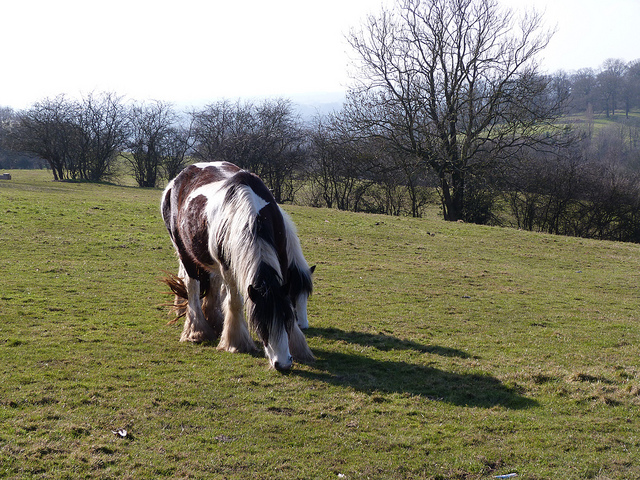What color is the horse? The horse has a striking black and white coat, which makes it quite distinctive in its natural setting. Is there any man-made feature visible in the picture? No, there don’t seem to be any man-made features such as fences or buildings visible in the picture, enhancing the pastoral and natural feel of the scene. 